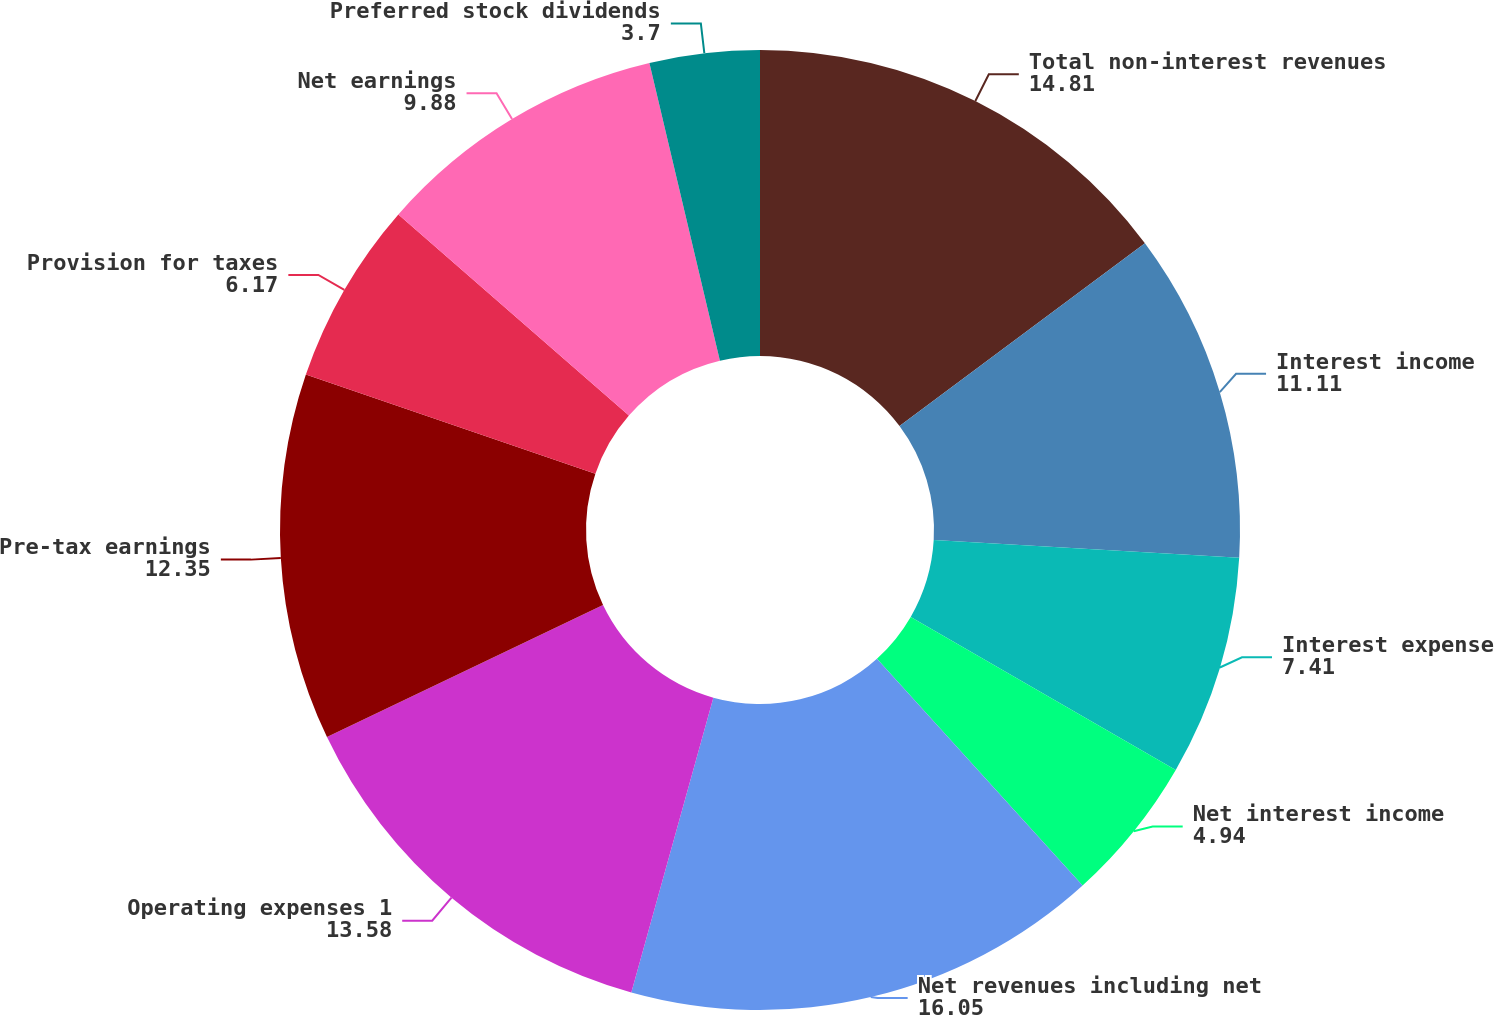Convert chart. <chart><loc_0><loc_0><loc_500><loc_500><pie_chart><fcel>Total non-interest revenues<fcel>Interest income<fcel>Interest expense<fcel>Net interest income<fcel>Net revenues including net<fcel>Operating expenses 1<fcel>Pre-tax earnings<fcel>Provision for taxes<fcel>Net earnings<fcel>Preferred stock dividends<nl><fcel>14.81%<fcel>11.11%<fcel>7.41%<fcel>4.94%<fcel>16.05%<fcel>13.58%<fcel>12.35%<fcel>6.17%<fcel>9.88%<fcel>3.7%<nl></chart> 